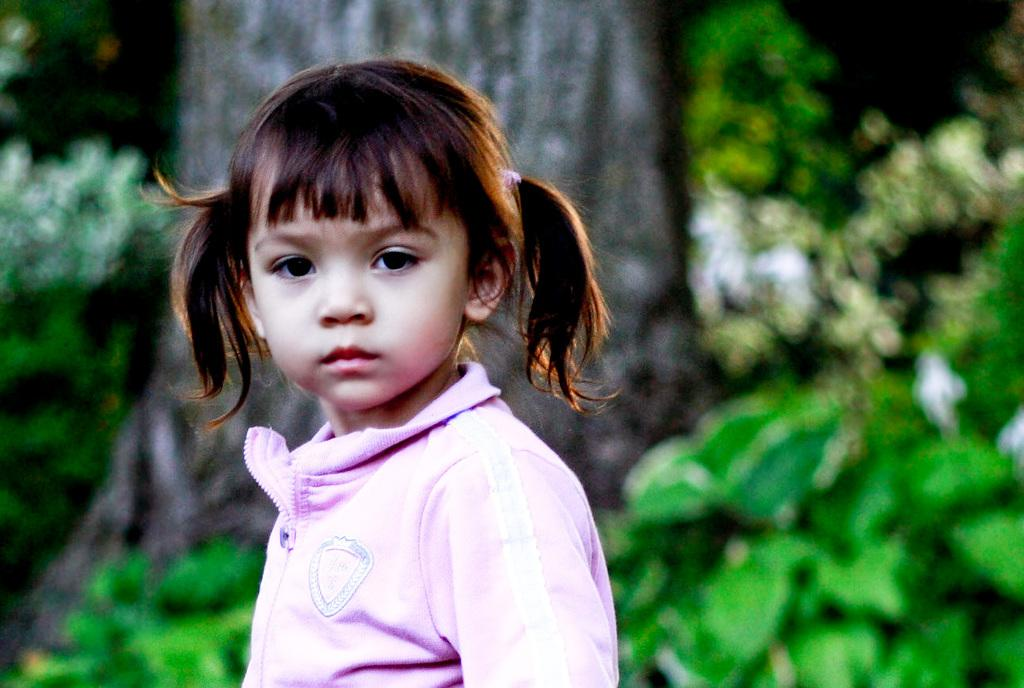Who is the main subject in the image? There is a girl in the middle of the image. What can be seen in the background of the image? There is a big tree in the background of the image. What type of vegetation is visible at the bottom of the image? There are green leaves at the bottom of the image. What year is depicted in the image? The image does not depict a specific year; it is a photograph of a girl, a tree, and green leaves. Can you see a frog in the image? There is no frog present in the image. 